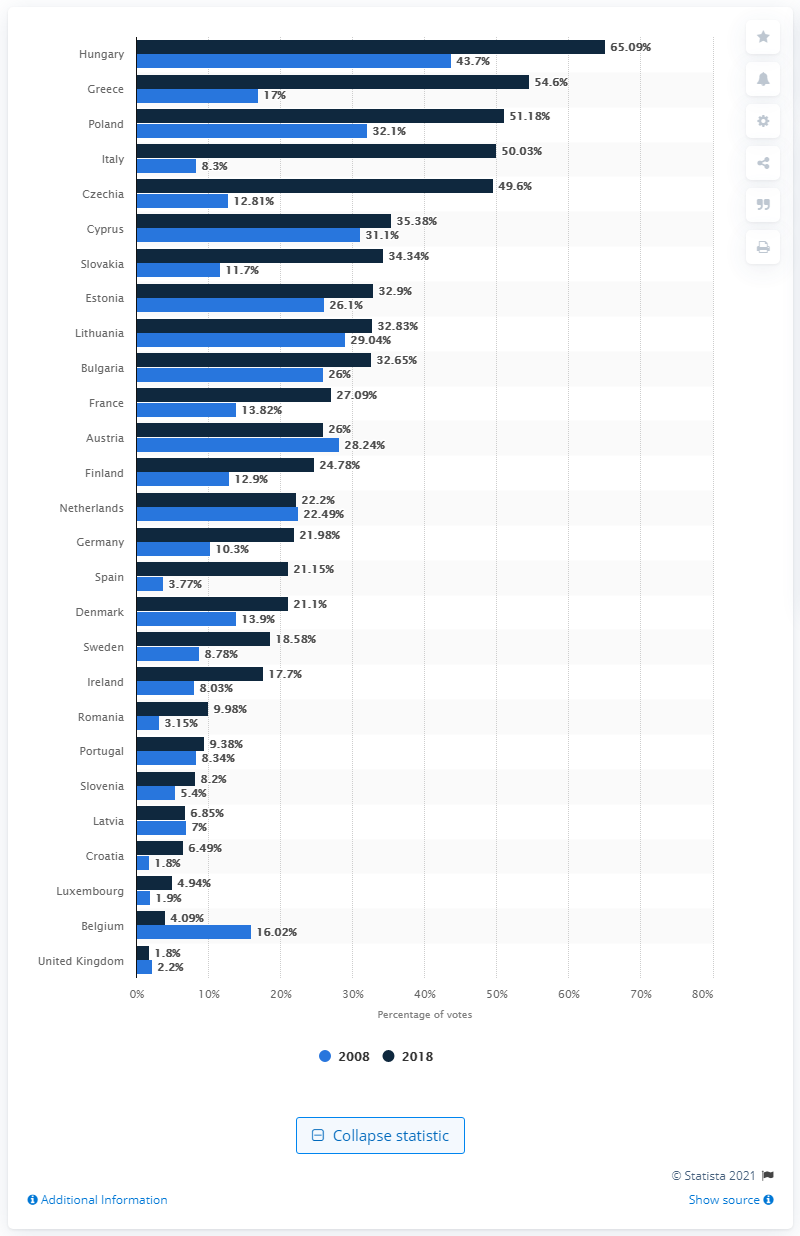Give some essential details in this illustration. Populist parties in the UK received 1.8% of the total votes cast in the most recent elections. According to the data, populist parties in the UK accounted for 1.8% of the votes cast in the last election. 